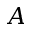Convert formula to latex. <formula><loc_0><loc_0><loc_500><loc_500>A</formula> 